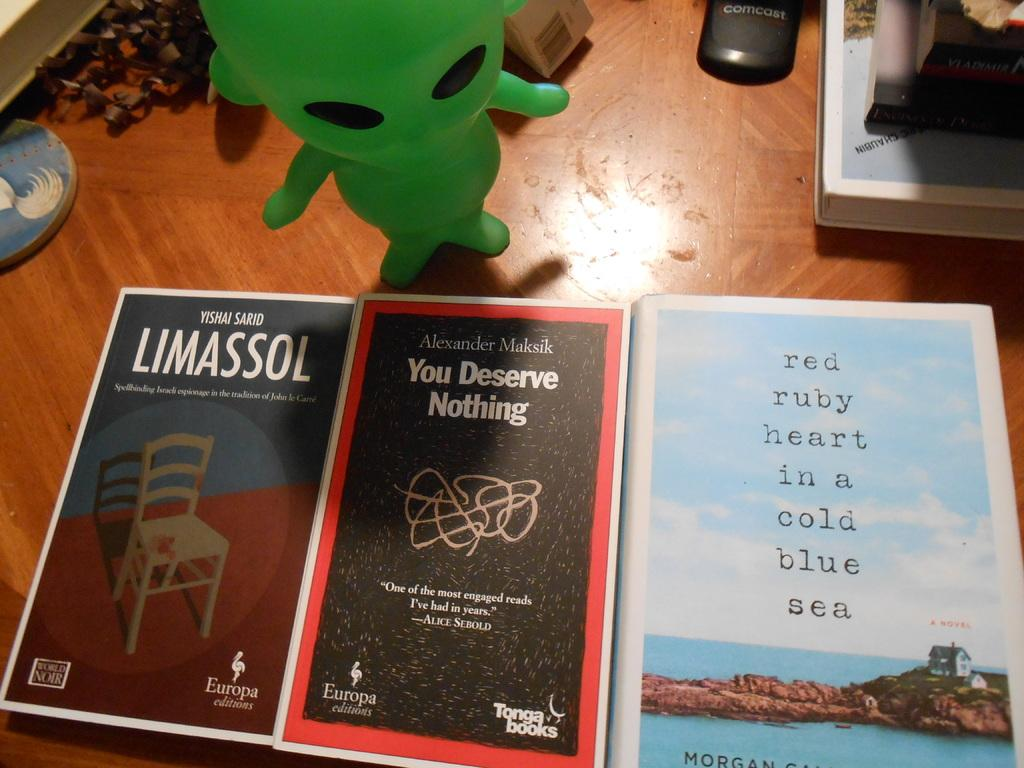Provide a one-sentence caption for the provided image. Three books are lined up on a table including one titled You Deserve Nothing while a green alien figurine stands by the books. 